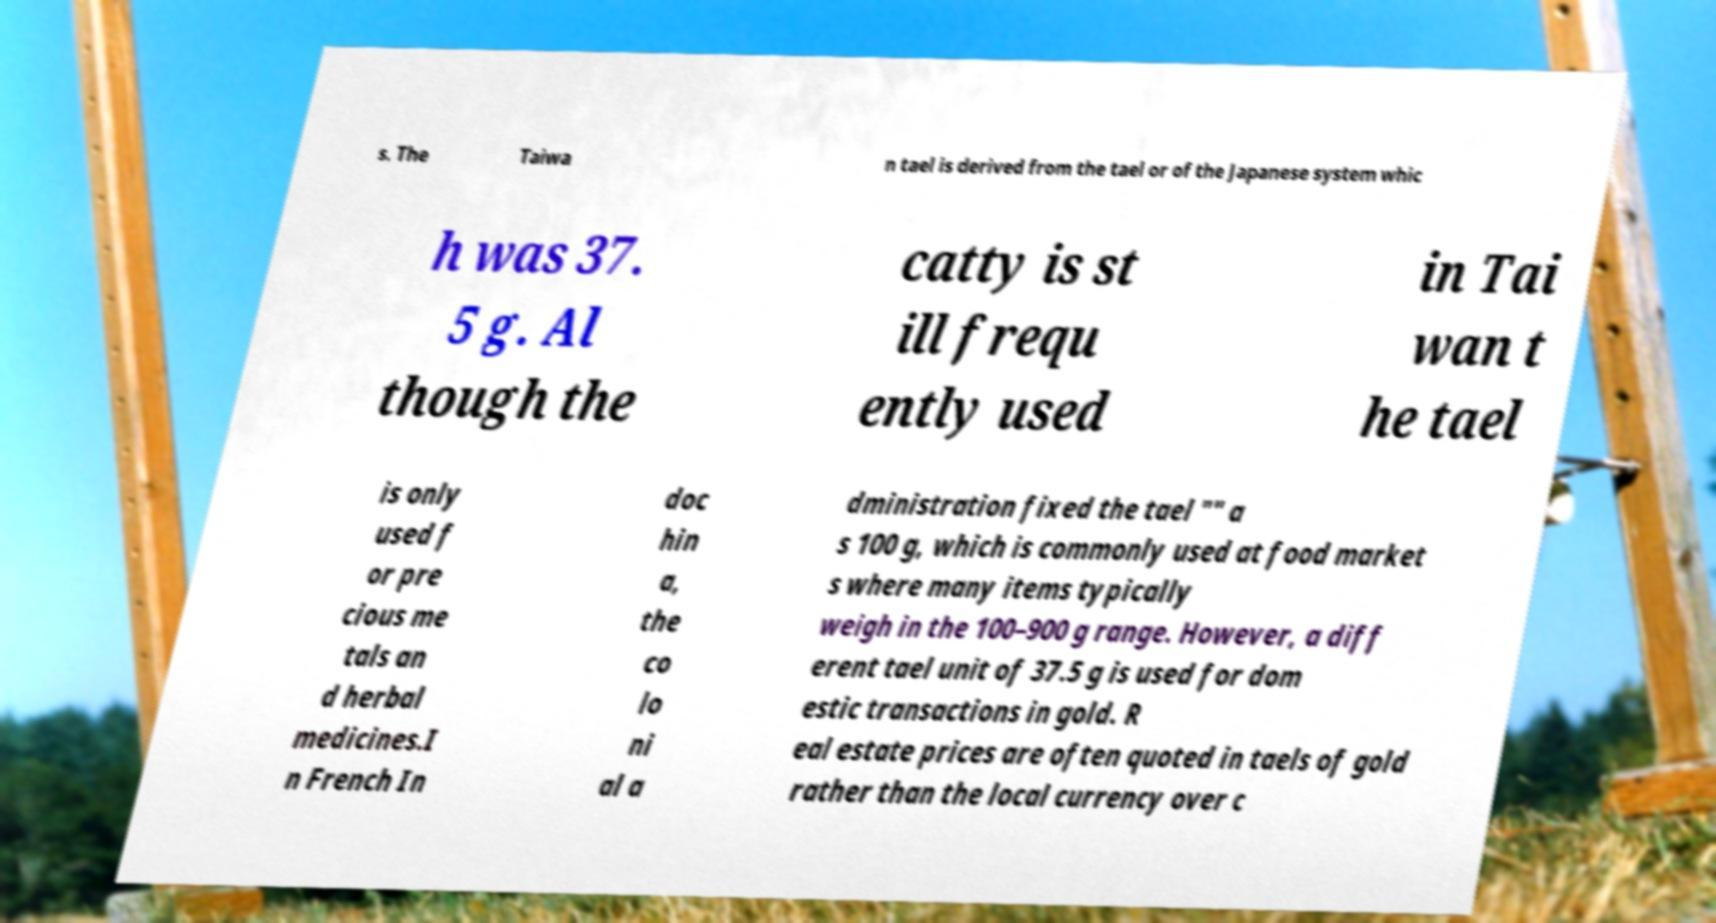There's text embedded in this image that I need extracted. Can you transcribe it verbatim? s. The Taiwa n tael is derived from the tael or of the Japanese system whic h was 37. 5 g. Al though the catty is st ill frequ ently used in Tai wan t he tael is only used f or pre cious me tals an d herbal medicines.I n French In doc hin a, the co lo ni al a dministration fixed the tael "" a s 100 g, which is commonly used at food market s where many items typically weigh in the 100–900 g range. However, a diff erent tael unit of 37.5 g is used for dom estic transactions in gold. R eal estate prices are often quoted in taels of gold rather than the local currency over c 